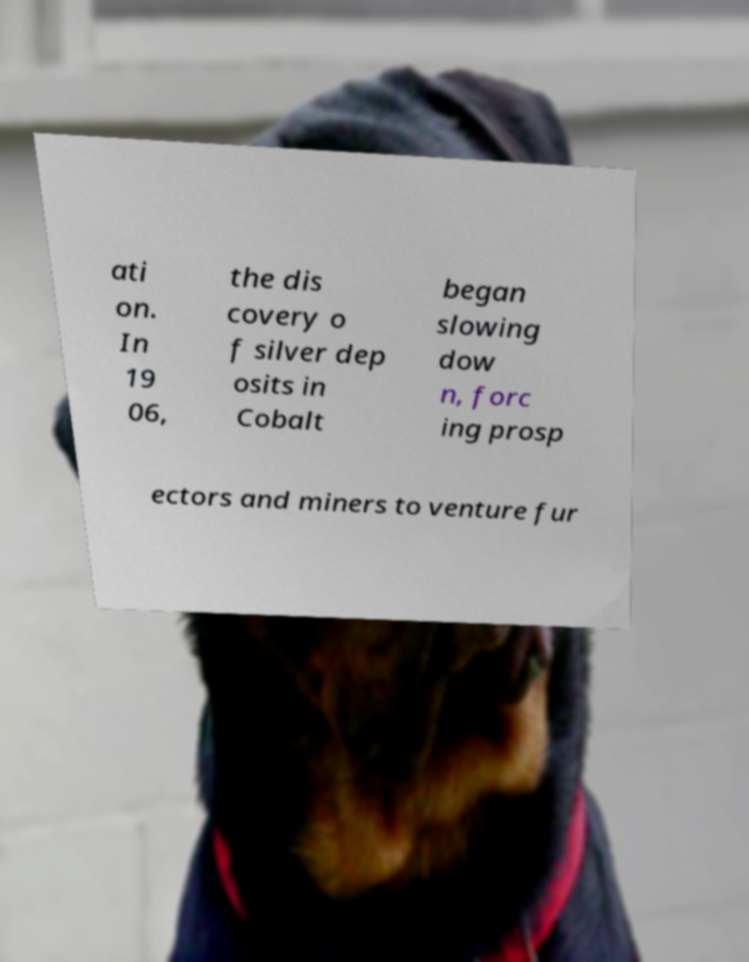Can you read and provide the text displayed in the image?This photo seems to have some interesting text. Can you extract and type it out for me? ati on. In 19 06, the dis covery o f silver dep osits in Cobalt began slowing dow n, forc ing prosp ectors and miners to venture fur 